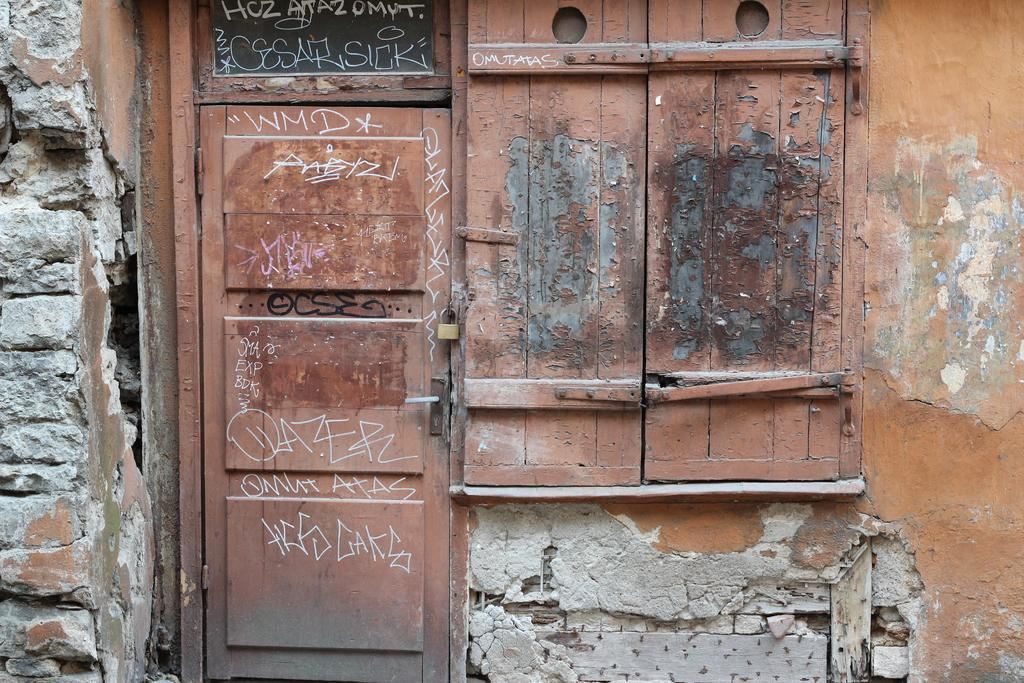What type of door is visible in the image? There is a wooden door in the image. Is there any text or markings on the wooden door? Yes, there is something written on the wooden door. What other wooden feature is present near the door? There is a wooden window beside the door. What type of nation is depicted in the image? There is no nation depicted in the image; it features a wooden door with writing and a wooden window. Is there a church visible in the image? There is no church present in the image. 